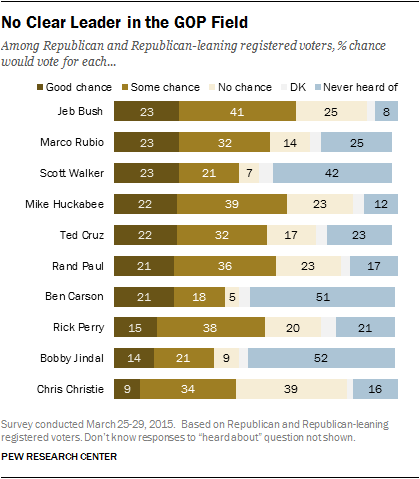Indicate a few pertinent items in this graphic. The number of people who have never heard of Bobby Jindal and Rick Perry is 31. Bobby Jindal, a Republican, has the highest blue bar. 